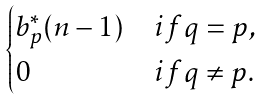Convert formula to latex. <formula><loc_0><loc_0><loc_500><loc_500>\begin{cases} b _ { p } ^ { * } ( n - 1 ) & i f q = p , \\ 0 & i f q \ne p . \end{cases}</formula> 